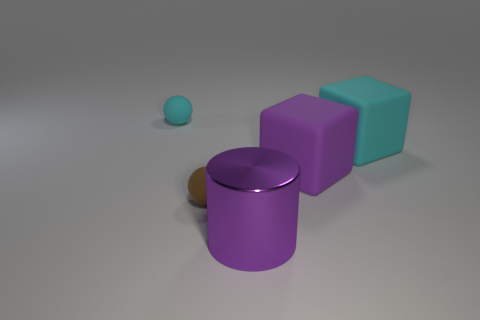There is a big rubber thing that is the same color as the big cylinder; what is its shape?
Give a very brief answer. Cube. What number of other objects are there of the same size as the brown sphere?
Keep it short and to the point. 1. What is the thing that is both on the left side of the shiny cylinder and in front of the big cyan matte block made of?
Keep it short and to the point. Rubber. Does the cyan rubber object that is on the right side of the cylinder have the same size as the purple cylinder?
Make the answer very short. Yes. What number of things are both on the right side of the cyan ball and left of the purple cylinder?
Provide a short and direct response. 1. There is a cyan rubber thing that is in front of the cyan object on the left side of the big purple cube; what number of purple objects are behind it?
Your answer should be compact. 0. What is the size of the matte block that is the same color as the large metal thing?
Make the answer very short. Large. What is the shape of the small brown thing?
Offer a very short reply. Sphere. What number of brown balls are made of the same material as the cyan ball?
Offer a very short reply. 1. What is the color of the other block that is made of the same material as the purple cube?
Your answer should be compact. Cyan. 